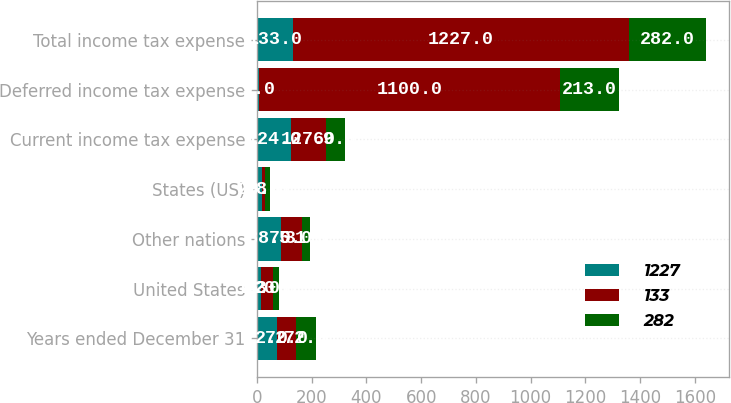Convert chart. <chart><loc_0><loc_0><loc_500><loc_500><stacked_bar_chart><ecel><fcel>Years ended December 31<fcel>United States<fcel>Other nations<fcel>States (US)<fcel>Current income tax expense<fcel>Deferred income tax expense<fcel>Total income tax expense<nl><fcel>1227<fcel>72<fcel>16<fcel>88<fcel>20<fcel>124<fcel>9<fcel>133<nl><fcel>133<fcel>72<fcel>43<fcel>75<fcel>9<fcel>127<fcel>1100<fcel>1227<nl><fcel>282<fcel>72<fcel>20<fcel>31<fcel>18<fcel>69<fcel>213<fcel>282<nl></chart> 